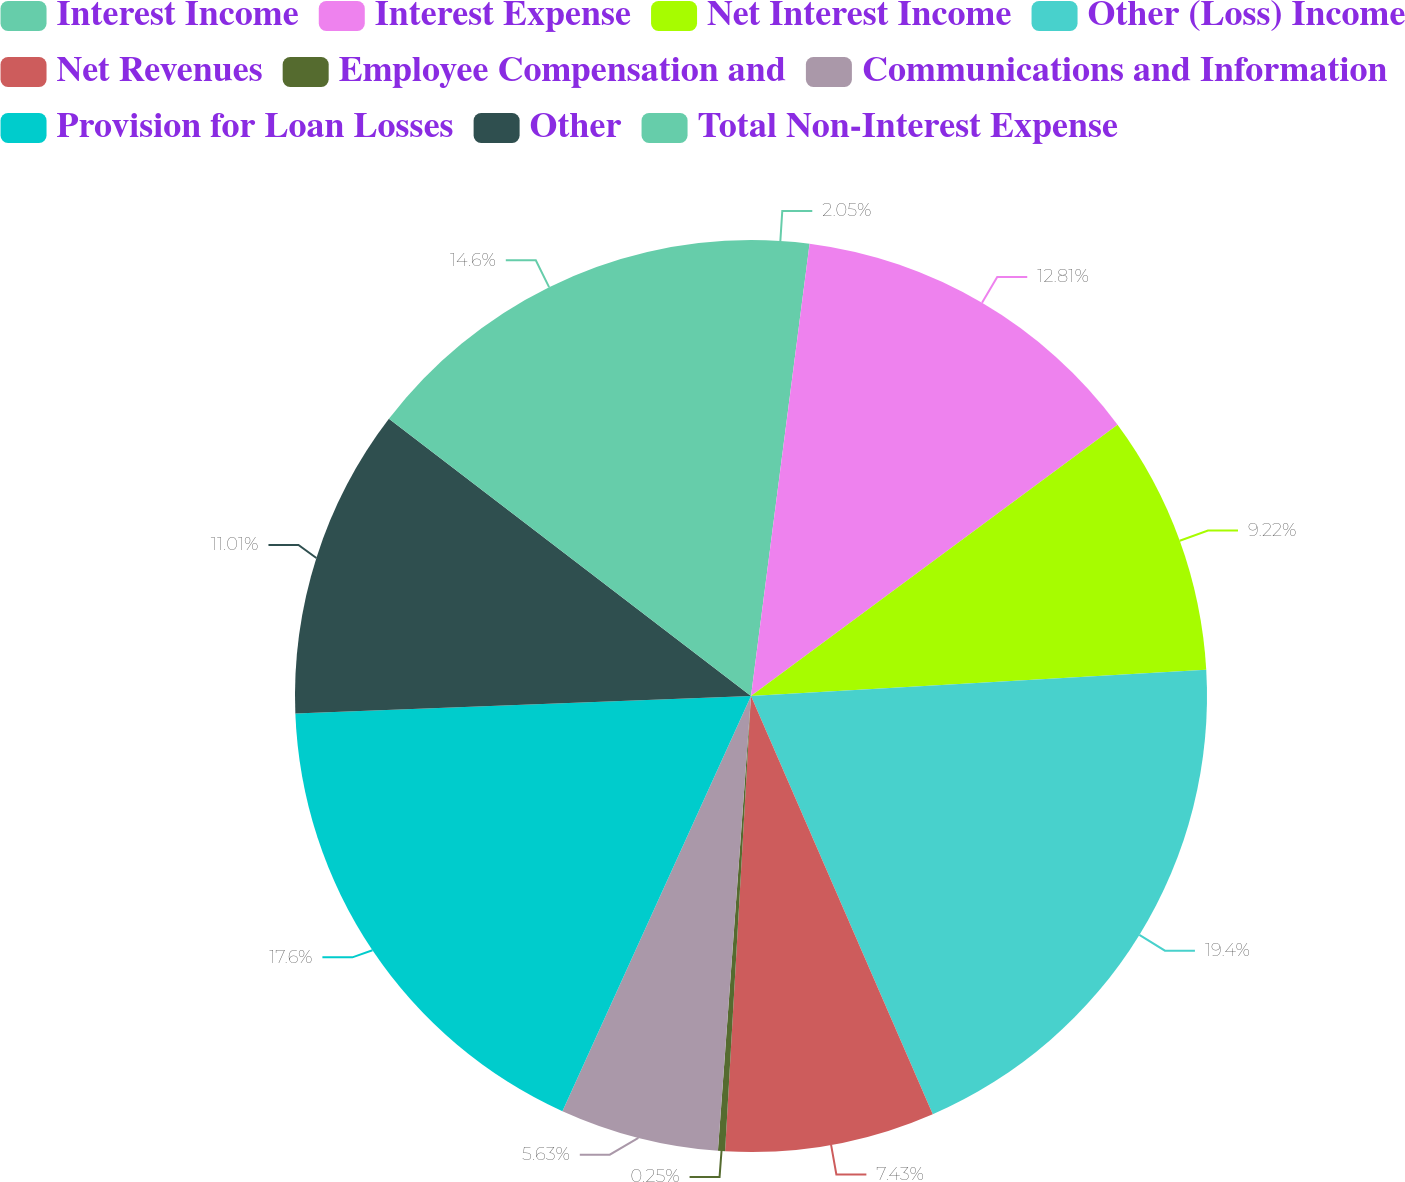<chart> <loc_0><loc_0><loc_500><loc_500><pie_chart><fcel>Interest Income<fcel>Interest Expense<fcel>Net Interest Income<fcel>Other (Loss) Income<fcel>Net Revenues<fcel>Employee Compensation and<fcel>Communications and Information<fcel>Provision for Loan Losses<fcel>Other<fcel>Total Non-Interest Expense<nl><fcel>2.05%<fcel>12.81%<fcel>9.22%<fcel>19.39%<fcel>7.43%<fcel>0.25%<fcel>5.63%<fcel>17.6%<fcel>11.01%<fcel>14.6%<nl></chart> 